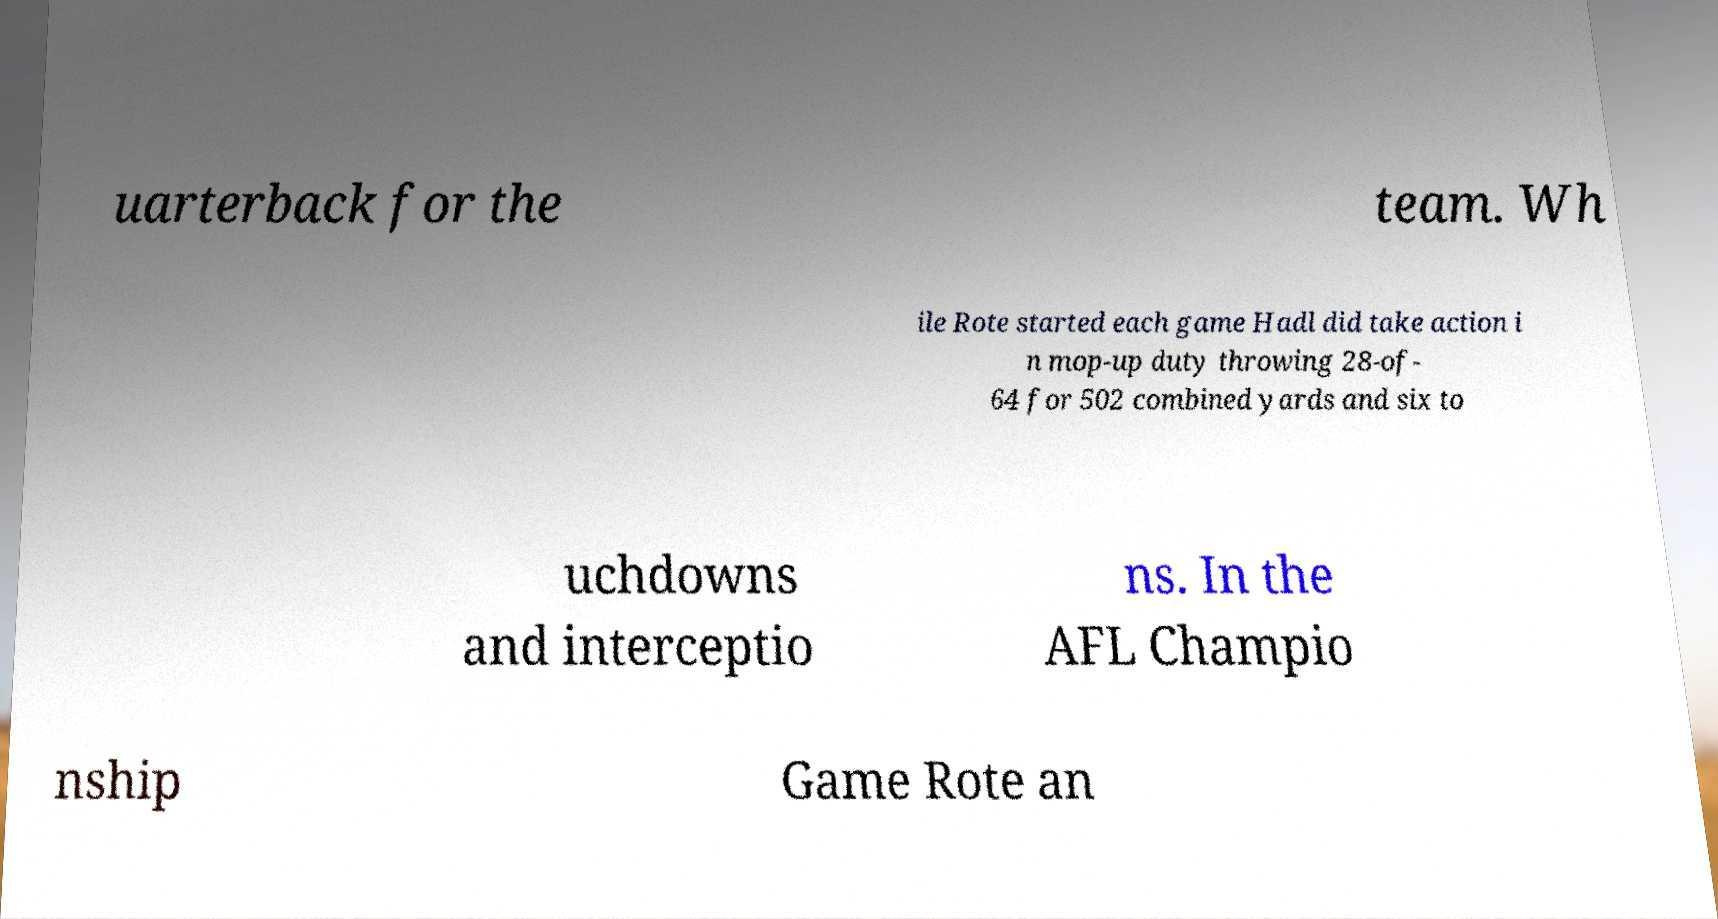What messages or text are displayed in this image? I need them in a readable, typed format. uarterback for the team. Wh ile Rote started each game Hadl did take action i n mop-up duty throwing 28-of- 64 for 502 combined yards and six to uchdowns and interceptio ns. In the AFL Champio nship Game Rote an 